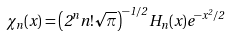Convert formula to latex. <formula><loc_0><loc_0><loc_500><loc_500>\chi _ { n } ( x ) = \left ( 2 ^ { n } n ! \sqrt { \pi } \right ) ^ { - 1 / 2 } H _ { n } ( x ) e ^ { - x ^ { 2 } / 2 }</formula> 